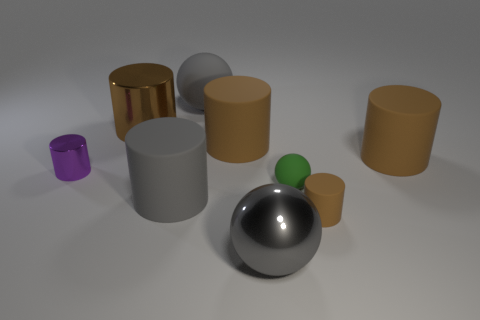There is a big gray object that is the same shape as the small metal thing; what material is it?
Provide a short and direct response. Rubber. Is there any other thing that is the same size as the brown metallic cylinder?
Ensure brevity in your answer.  Yes. Are there any spheres?
Your response must be concise. Yes. What material is the gray object that is behind the big rubber cylinder to the left of the big thing behind the large shiny cylinder?
Your answer should be very brief. Rubber. Do the green rubber thing and the shiny thing in front of the small brown cylinder have the same shape?
Your response must be concise. Yes. What number of red rubber objects are the same shape as the green thing?
Provide a succinct answer. 0. The large gray shiny thing is what shape?
Make the answer very short. Sphere. What size is the brown matte cylinder that is in front of the gray cylinder in front of the purple cylinder?
Give a very brief answer. Small. How many objects are big gray shiny balls or purple cylinders?
Make the answer very short. 2. Does the green thing have the same shape as the big brown shiny object?
Offer a terse response. No. 